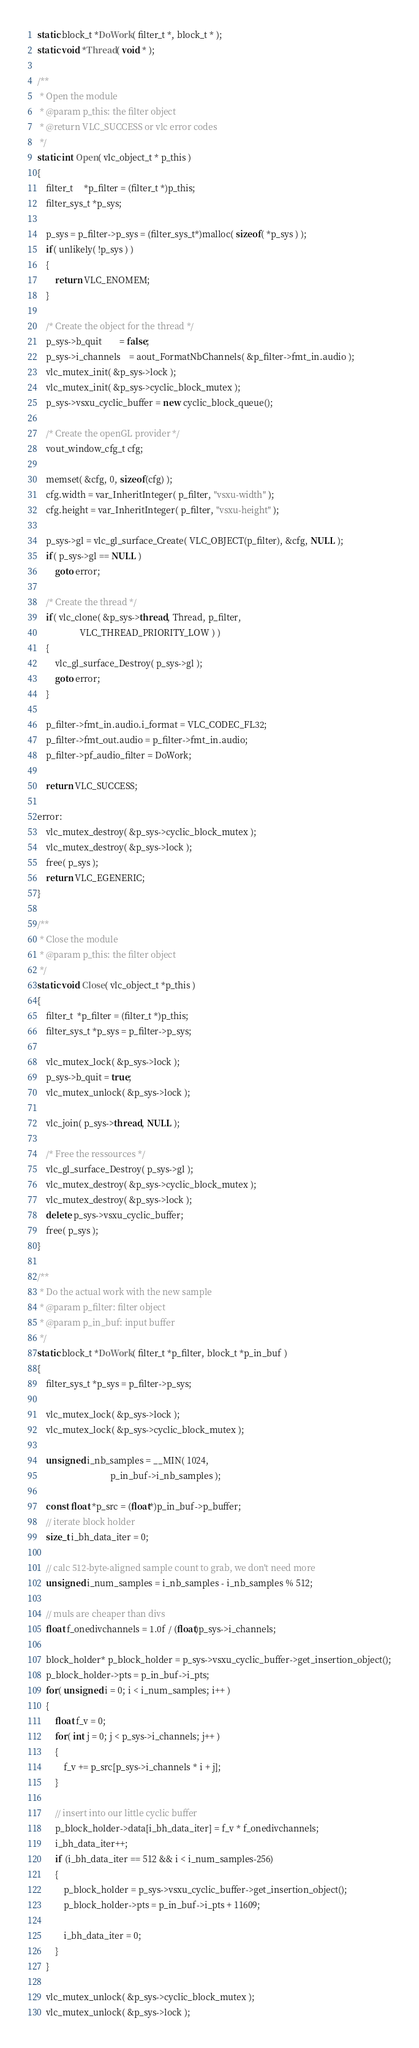Convert code to text. <code><loc_0><loc_0><loc_500><loc_500><_C++_>static block_t *DoWork( filter_t *, block_t * );
static void *Thread( void * );

/**
 * Open the module
 * @param p_this: the filter object
 * @return VLC_SUCCESS or vlc error codes
 */
static int Open( vlc_object_t * p_this )
{
    filter_t     *p_filter = (filter_t *)p_this;
    filter_sys_t *p_sys;

    p_sys = p_filter->p_sys = (filter_sys_t*)malloc( sizeof( *p_sys ) );
    if( unlikely( !p_sys ) )
    {
        return VLC_ENOMEM;
    }

    /* Create the object for the thread */
    p_sys->b_quit        = false;
    p_sys->i_channels    = aout_FormatNbChannels( &p_filter->fmt_in.audio );
    vlc_mutex_init( &p_sys->lock );
    vlc_mutex_init( &p_sys->cyclic_block_mutex );
    p_sys->vsxu_cyclic_buffer = new cyclic_block_queue();

    /* Create the openGL provider */
    vout_window_cfg_t cfg;

    memset( &cfg, 0, sizeof(cfg) );
    cfg.width = var_InheritInteger( p_filter, "vsxu-width" );
    cfg.height = var_InheritInteger( p_filter, "vsxu-height" );

    p_sys->gl = vlc_gl_surface_Create( VLC_OBJECT(p_filter), &cfg, NULL );
    if( p_sys->gl == NULL )
        goto error;

    /* Create the thread */
    if( vlc_clone( &p_sys->thread, Thread, p_filter,
                   VLC_THREAD_PRIORITY_LOW ) )
    {
        vlc_gl_surface_Destroy( p_sys->gl );
        goto error;
    }

    p_filter->fmt_in.audio.i_format = VLC_CODEC_FL32;
    p_filter->fmt_out.audio = p_filter->fmt_in.audio;
    p_filter->pf_audio_filter = DoWork;

    return VLC_SUCCESS;

error:
    vlc_mutex_destroy( &p_sys->cyclic_block_mutex );
    vlc_mutex_destroy( &p_sys->lock );
    free( p_sys );
    return VLC_EGENERIC;
}

/**
 * Close the module
 * @param p_this: the filter object
 */
static void Close( vlc_object_t *p_this )
{
    filter_t  *p_filter = (filter_t *)p_this;
    filter_sys_t *p_sys = p_filter->p_sys;

    vlc_mutex_lock( &p_sys->lock );
    p_sys->b_quit = true;
    vlc_mutex_unlock( &p_sys->lock );

    vlc_join( p_sys->thread, NULL );

    /* Free the ressources */
    vlc_gl_surface_Destroy( p_sys->gl );
    vlc_mutex_destroy( &p_sys->cyclic_block_mutex );
    vlc_mutex_destroy( &p_sys->lock );
    delete p_sys->vsxu_cyclic_buffer;
    free( p_sys );
}

/**
 * Do the actual work with the new sample
 * @param p_filter: filter object
 * @param p_in_buf: input buffer
 */
static block_t *DoWork( filter_t *p_filter, block_t *p_in_buf )
{
    filter_sys_t *p_sys = p_filter->p_sys;

    vlc_mutex_lock( &p_sys->lock );
    vlc_mutex_lock( &p_sys->cyclic_block_mutex );

    unsigned i_nb_samples = __MIN( 1024,
                                 p_in_buf->i_nb_samples );

    const float *p_src = (float*)p_in_buf->p_buffer;
    // iterate block holder
    size_t i_bh_data_iter = 0;

    // calc 512-byte-aligned sample count to grab, we don't need more
    unsigned i_num_samples = i_nb_samples - i_nb_samples % 512;

    // muls are cheaper than divs
    float f_onedivchannels = 1.0f / (float)p_sys->i_channels;

    block_holder* p_block_holder = p_sys->vsxu_cyclic_buffer->get_insertion_object();
    p_block_holder->pts = p_in_buf->i_pts;
    for( unsigned i = 0; i < i_num_samples; i++ )
    {
        float f_v = 0;
        for( int j = 0; j < p_sys->i_channels; j++ )
        {
            f_v += p_src[p_sys->i_channels * i + j];
        }

        // insert into our little cyclic buffer
        p_block_holder->data[i_bh_data_iter] = f_v * f_onedivchannels;
        i_bh_data_iter++;
        if (i_bh_data_iter == 512 && i < i_num_samples-256)
        {
            p_block_holder = p_sys->vsxu_cyclic_buffer->get_insertion_object();
            p_block_holder->pts = p_in_buf->i_pts + 11609;

            i_bh_data_iter = 0;
        }
    }

    vlc_mutex_unlock( &p_sys->cyclic_block_mutex );
    vlc_mutex_unlock( &p_sys->lock );</code> 